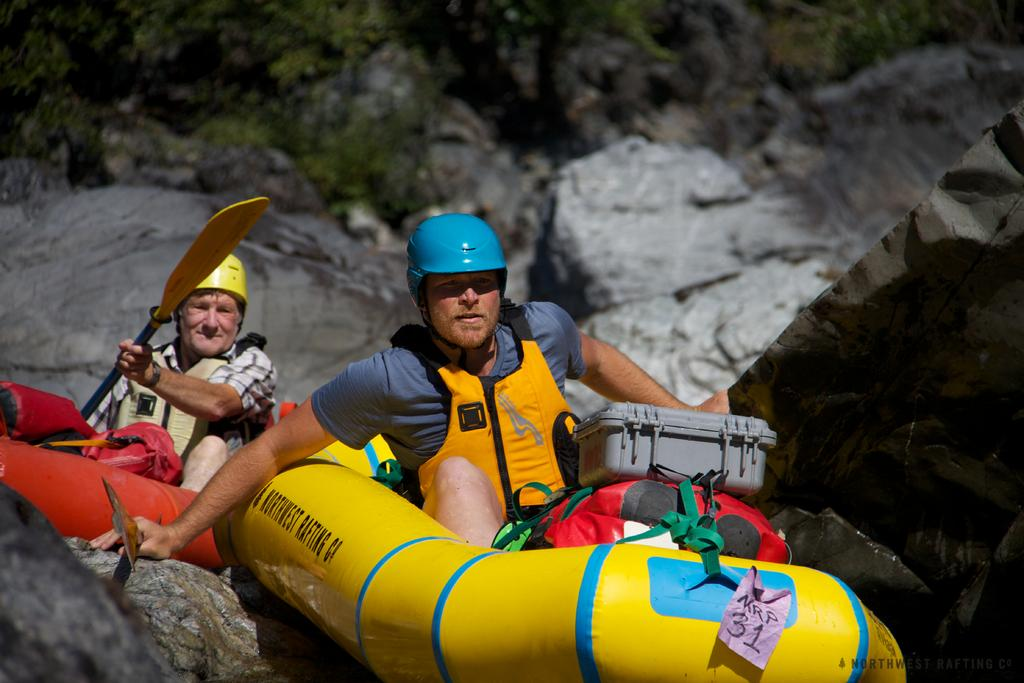What activity are the people in the image engaged in? The people in the image are rafting. What objects can be seen in the image besides the people? There are boxes and backpacks visible in the image. What can be seen in the background of the image? There are stones and trees in the background of the image. How does the growth of the trees in the image affect the wilderness? The image does not provide information about the growth of the trees or the wilderness, so it is not possible to answer this question based on the image. 